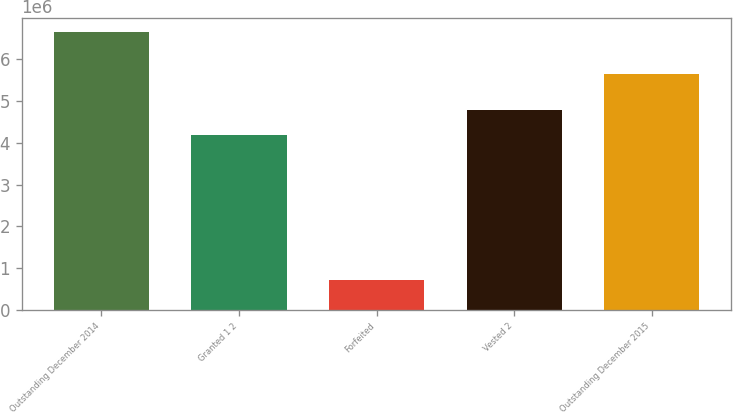<chart> <loc_0><loc_0><loc_500><loc_500><bar_chart><fcel>Outstanding December 2014<fcel>Granted 1 2<fcel>Forfeited<fcel>Vested 2<fcel>Outstanding December 2015<nl><fcel>6.65687e+06<fcel>4.19318e+06<fcel>726013<fcel>4.78626e+06<fcel>5.64916e+06<nl></chart> 